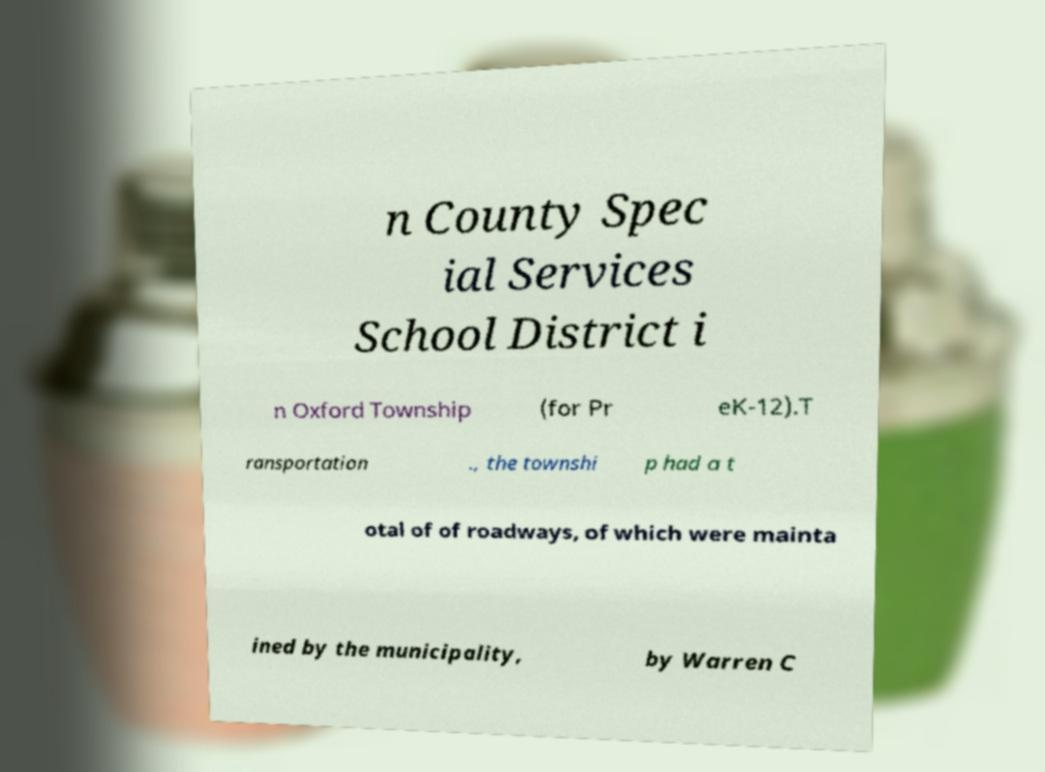Could you extract and type out the text from this image? n County Spec ial Services School District i n Oxford Township (for Pr eK-12).T ransportation ., the townshi p had a t otal of of roadways, of which were mainta ined by the municipality, by Warren C 